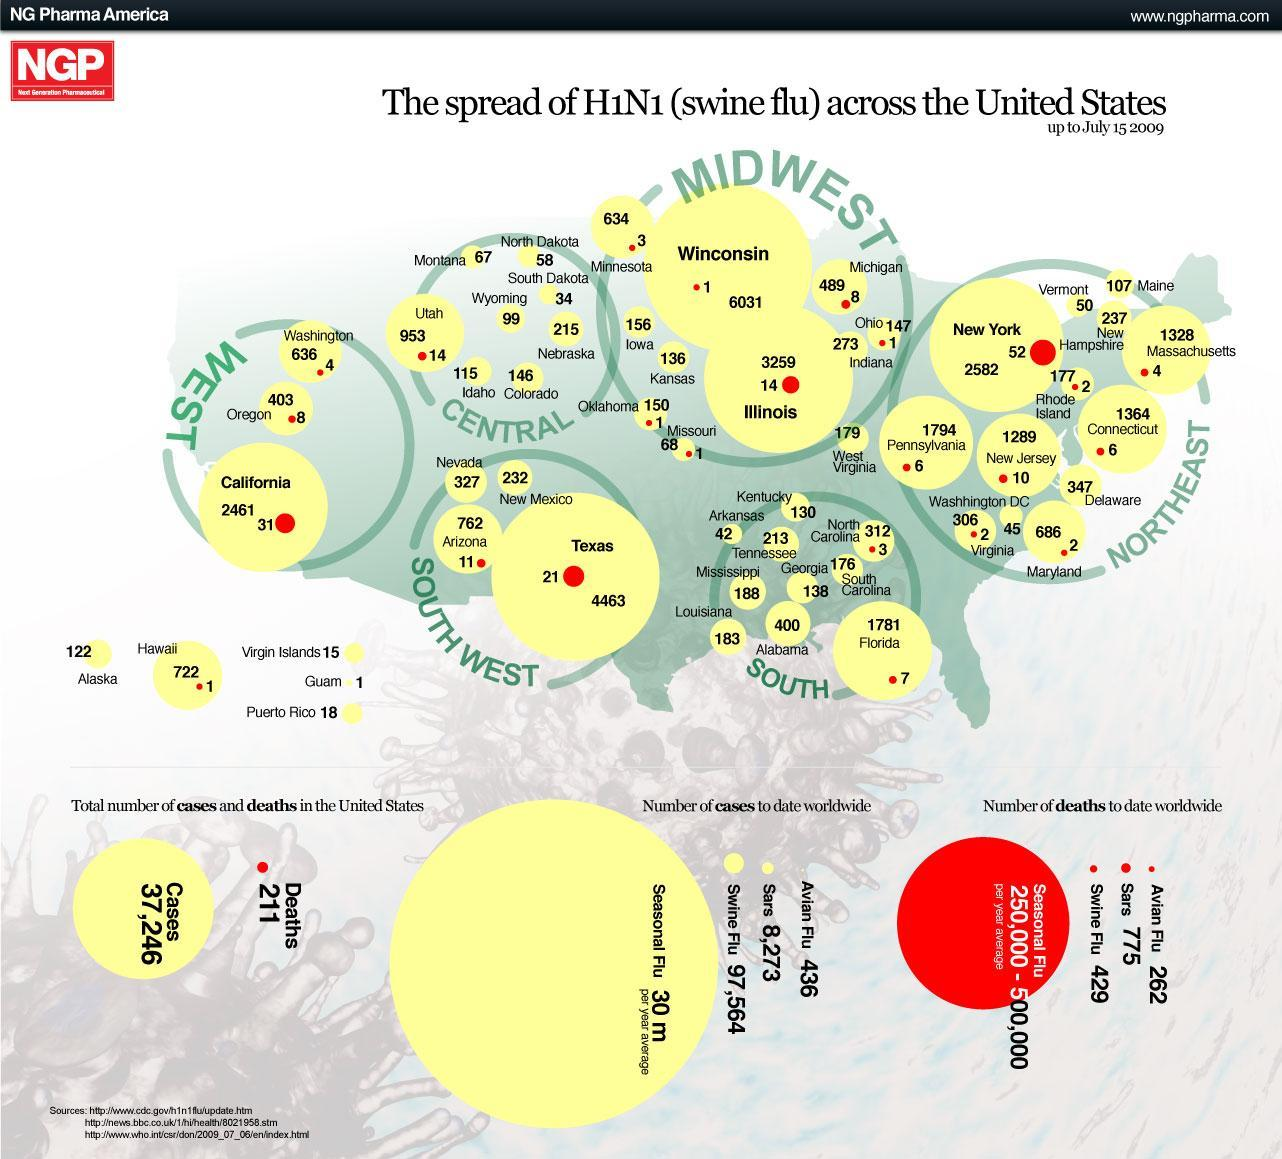What was the number of deaths in Hawaii due to Swine Flu?
Answer the question with a short phrase. 1 How many Swine Flu cases were reported in Georgia? 138 How many deaths in Utah due to H1N1? 14 What is the total number of death cases reported in all of the states in the Southern region? 10 Which state has higher number of Swine Flu cases - New York or Massachusetts? New York Which state had 3259 H1N1 cases reported? Illinois Which state in the Southwest region has highest number of H1N1 cases? Texas In which state was the highest number of deaths due to Swine Flu reported? New York How many H1N1 cases were reported in Wisconsin? 6031 Which region has two states with very high number of H1N1 cases? Midwest 